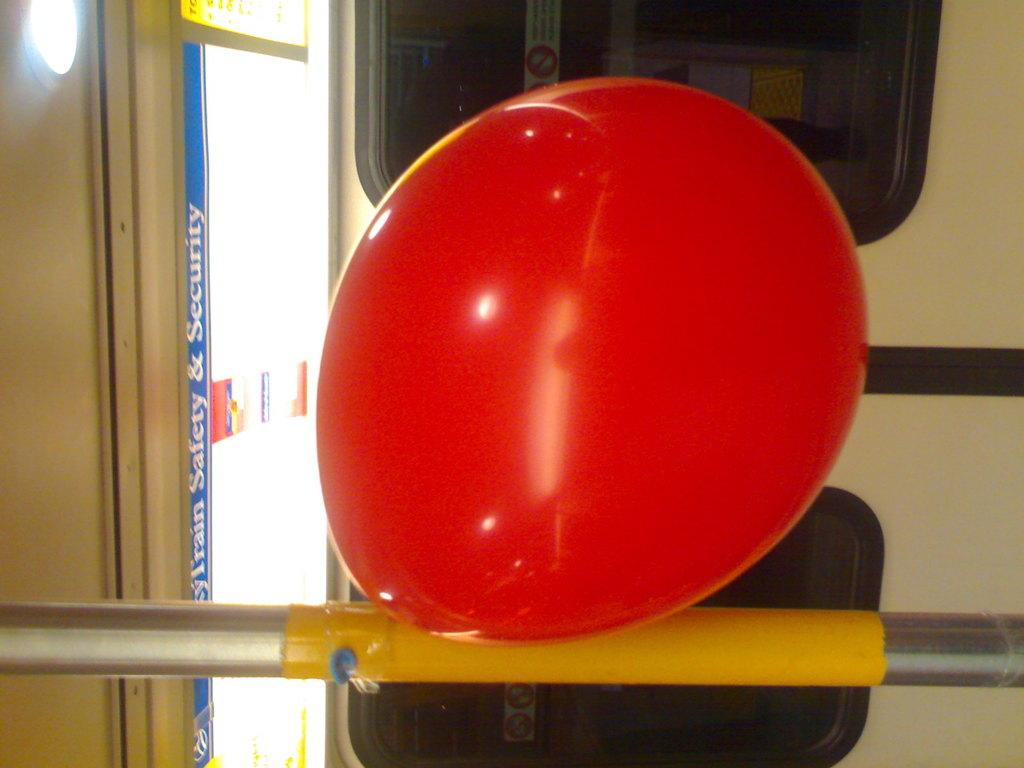What is attached to the metal rod in the image? There is a balloon on a metal rod in the image. What can be seen behind the balloon? There are glass windows behind the balloon. Where is the poster located in the image? The poster is beside the door in the image. What type of disease is the son helping to cure in the image? There is no son or disease present in the image. 